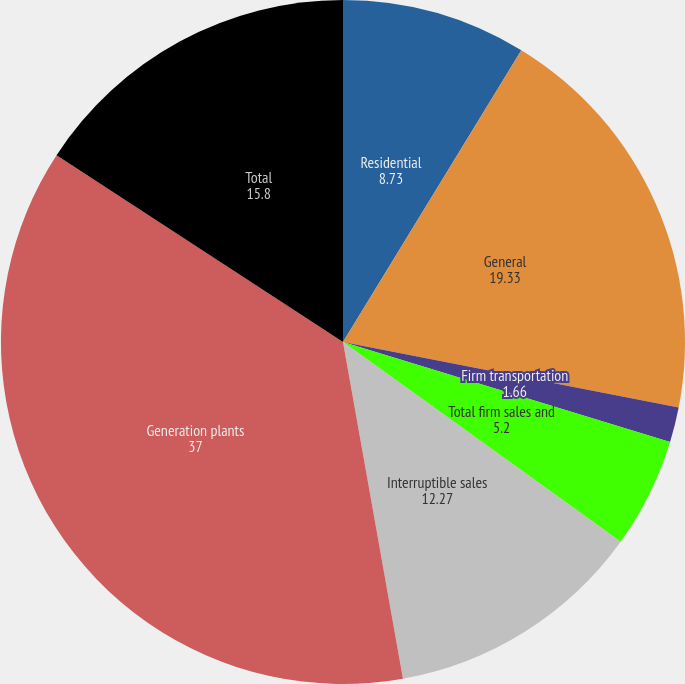Convert chart. <chart><loc_0><loc_0><loc_500><loc_500><pie_chart><fcel>Residential<fcel>General<fcel>Firm transportation<fcel>Total firm sales and<fcel>Interruptible sales<fcel>Generation plants<fcel>Total<nl><fcel>8.73%<fcel>19.33%<fcel>1.66%<fcel>5.2%<fcel>12.27%<fcel>37.0%<fcel>15.8%<nl></chart> 